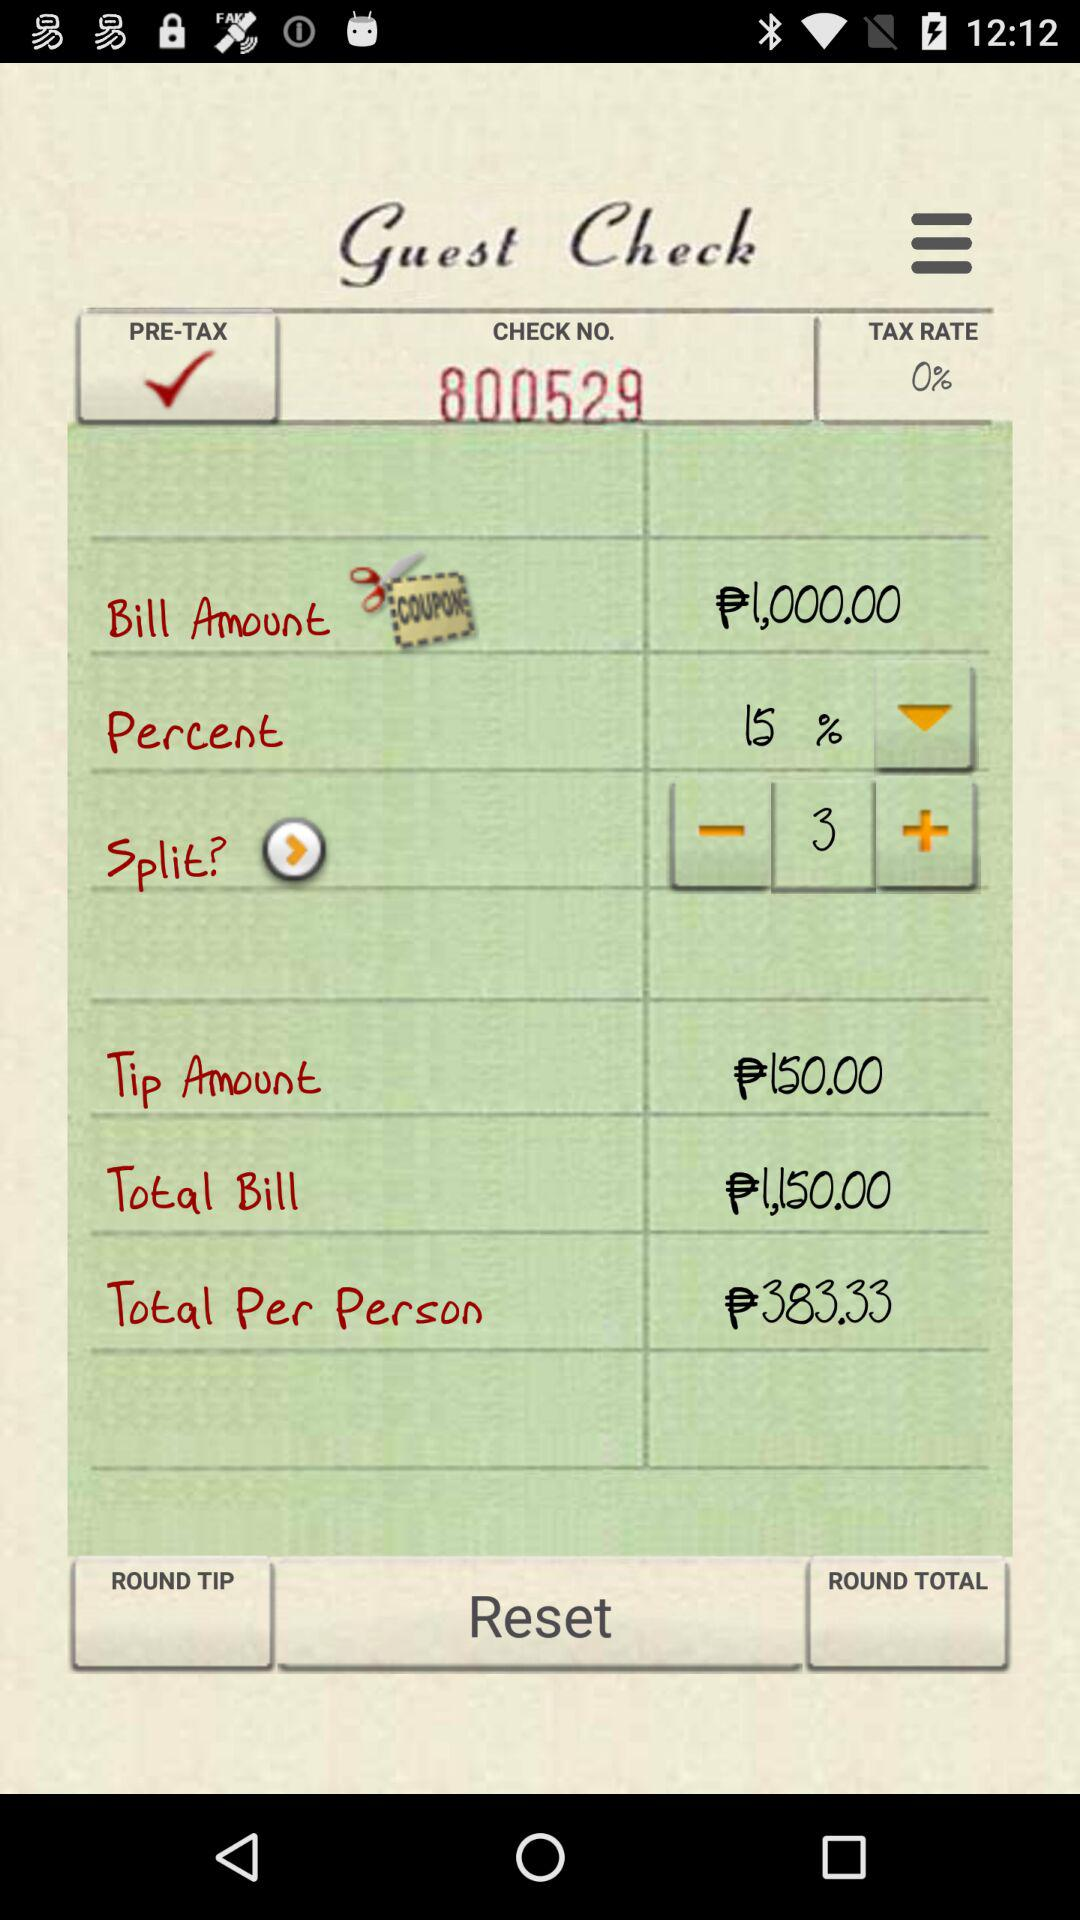What percentage is mentioned? The mentioned percentage is 15. 